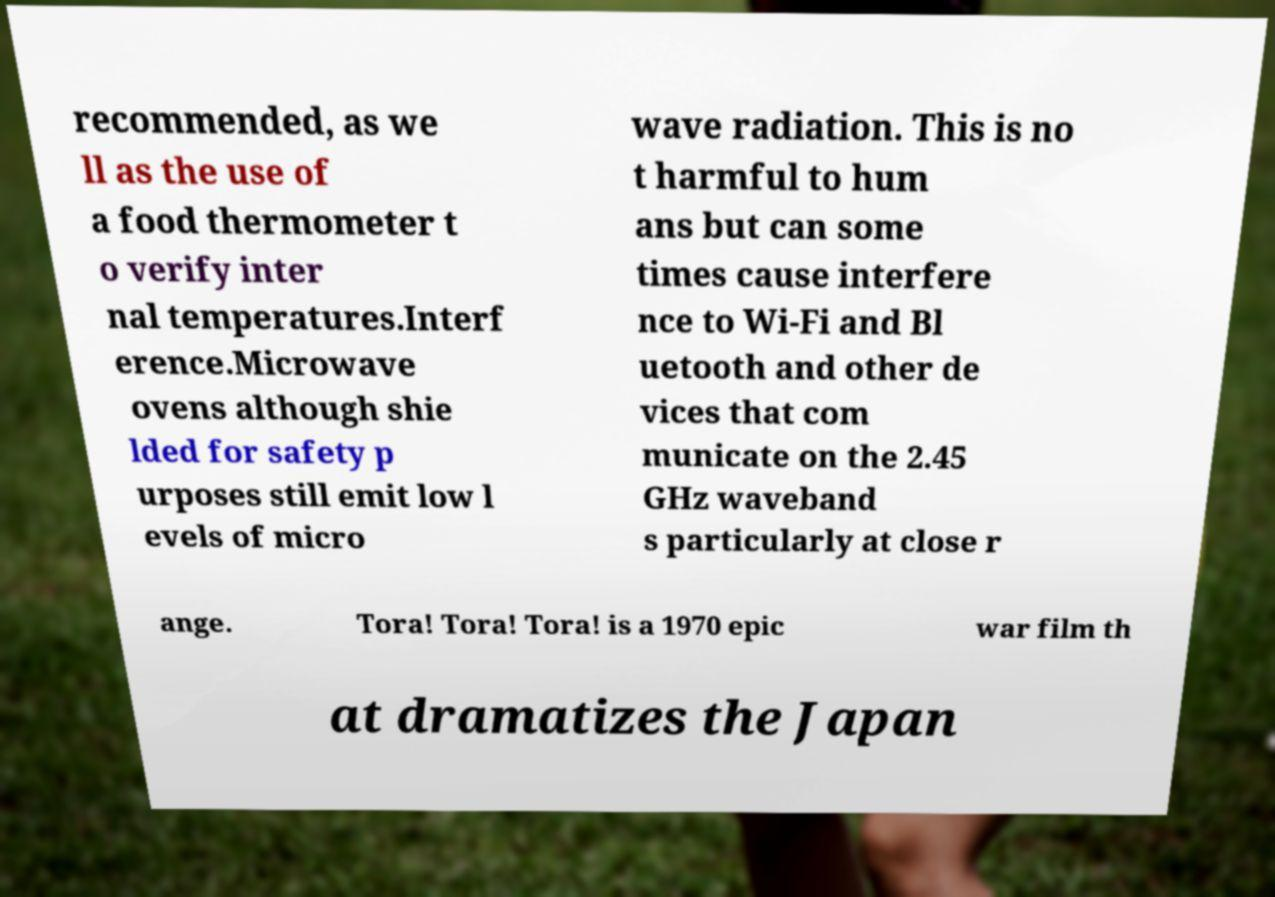There's text embedded in this image that I need extracted. Can you transcribe it verbatim? recommended, as we ll as the use of a food thermometer t o verify inter nal temperatures.Interf erence.Microwave ovens although shie lded for safety p urposes still emit low l evels of micro wave radiation. This is no t harmful to hum ans but can some times cause interfere nce to Wi-Fi and Bl uetooth and other de vices that com municate on the 2.45 GHz waveband s particularly at close r ange. Tora! Tora! Tora! is a 1970 epic war film th at dramatizes the Japan 